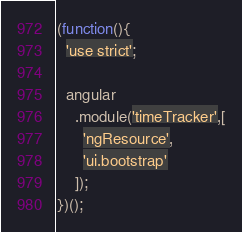<code> <loc_0><loc_0><loc_500><loc_500><_JavaScript_>(function(){
  'use strict';

  angular
    .module('timeTracker',[
      'ngResource',
      'ui.bootstrap'
    ]);
})();
</code> 